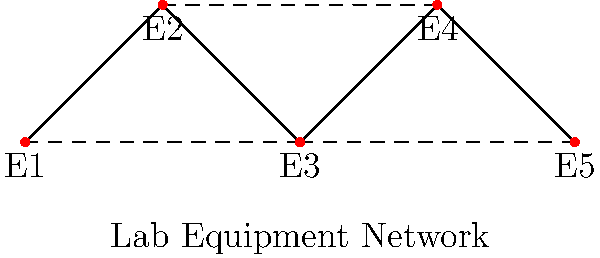In the given schematic of lab equipment connections, what is the network topology efficiency in terms of the average path length between any two pieces of equipment? Assume each connection (solid or dashed) has a unit length. To determine the network topology efficiency, we need to calculate the average path length between all pairs of equipment. Let's proceed step-by-step:

1. Identify the number of nodes (equipment pieces): $n = 5$

2. Calculate the total number of possible pairs: $\binom{5}{2} = 10$

3. Find the shortest path length for each pair:
   E1 to E2: 1
   E1 to E3: 1
   E1 to E4: 2
   E1 to E5: 2
   E2 to E3: 1
   E2 to E4: 1
   E2 to E5: 2
   E3 to E4: 1
   E3 to E5: 1
   E4 to E5: 1

4. Sum of all shortest paths: $1 + 1 + 2 + 2 + 1 + 1 + 2 + 1 + 1 + 1 = 13$

5. Calculate the average path length:
   $\text{Average Path Length} = \frac{\text{Sum of shortest paths}}{\text{Number of pairs}} = \frac{13}{10} = 1.3$

The network topology efficiency is inversely related to the average path length. A lower average path length indicates higher efficiency.
Answer: 1.3 